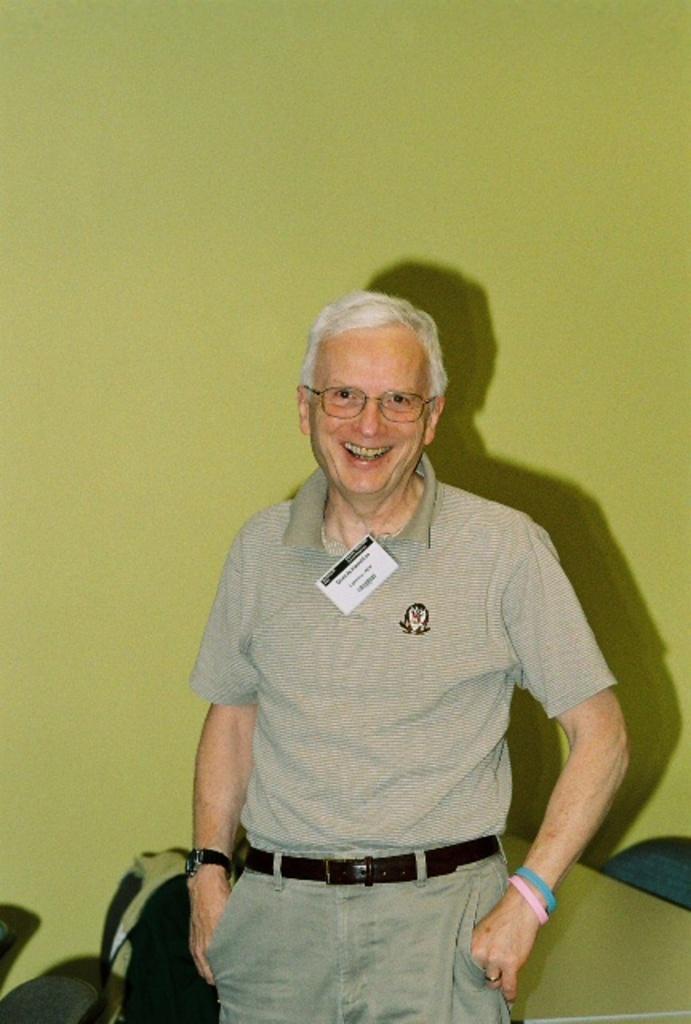Describe this image in one or two sentences. As we can see in the image there is a green color wall and man standing. 